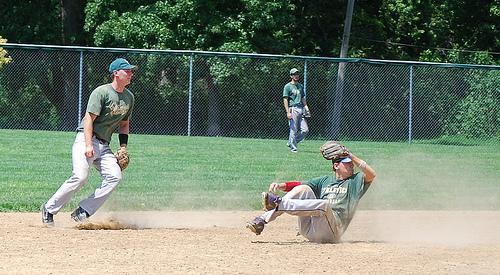How many people are there?
Give a very brief answer. 3. 